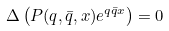Convert formula to latex. <formula><loc_0><loc_0><loc_500><loc_500>\Delta \left ( P ( q , \bar { q } , x ) e ^ { q \bar { q } x } \right ) = 0</formula> 